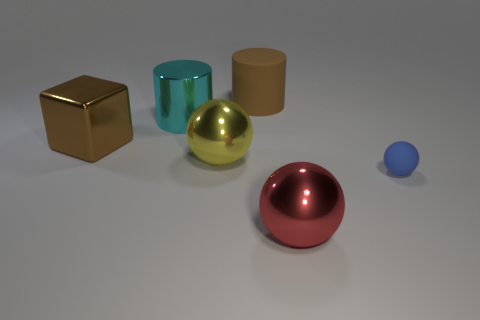What number of cylinders are on the right side of the large yellow thing and in front of the big brown cylinder?
Provide a short and direct response. 0. Does the small blue ball have the same material as the big cyan cylinder?
Give a very brief answer. No. There is a matte thing that is to the left of the metallic ball that is in front of the big sphere behind the tiny blue object; what shape is it?
Offer a very short reply. Cylinder. What material is the big object that is both on the right side of the yellow object and in front of the large metal cylinder?
Keep it short and to the point. Metal. There is a metallic object that is behind the big block left of the large thing behind the shiny cylinder; what color is it?
Offer a terse response. Cyan. How many brown things are large metallic cubes or metallic cylinders?
Ensure brevity in your answer.  1. What number of other things are the same size as the rubber ball?
Your answer should be very brief. 0. How many large cyan shiny objects are there?
Your answer should be compact. 1. Is there any other thing that is the same shape as the large brown metallic thing?
Provide a short and direct response. No. Is the material of the cylinder that is in front of the rubber cylinder the same as the yellow sphere that is left of the small sphere?
Offer a terse response. Yes. 